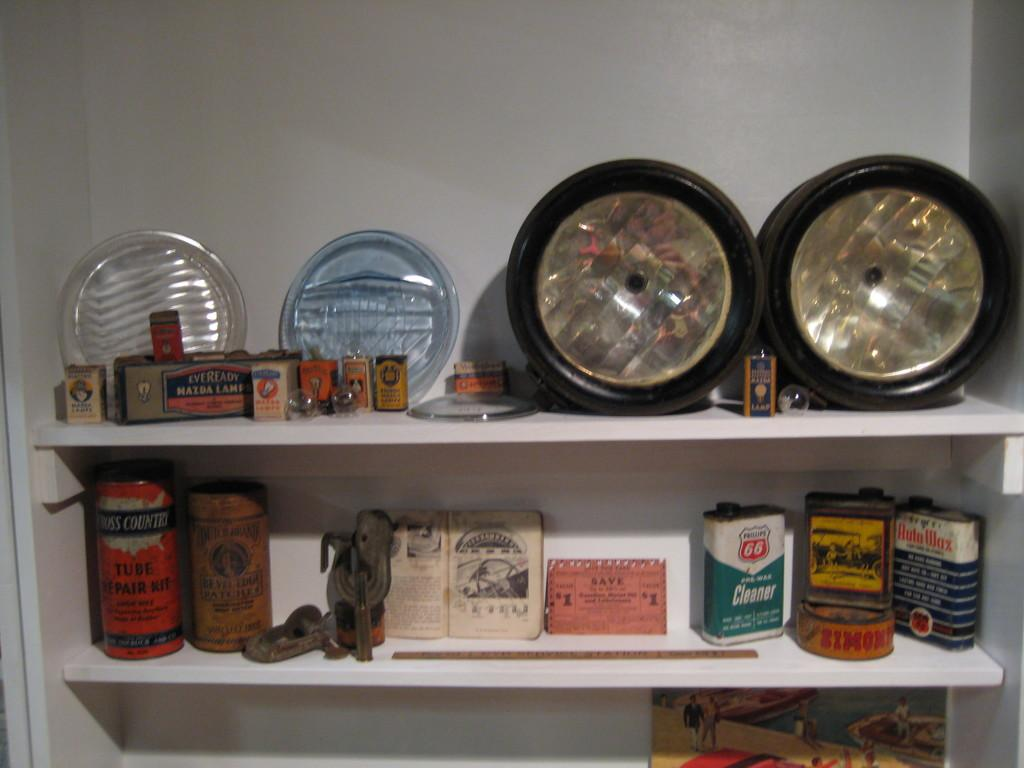<image>
Summarize the visual content of the image. Shelf full of many items including a can that says "Tube Repair Kit". 